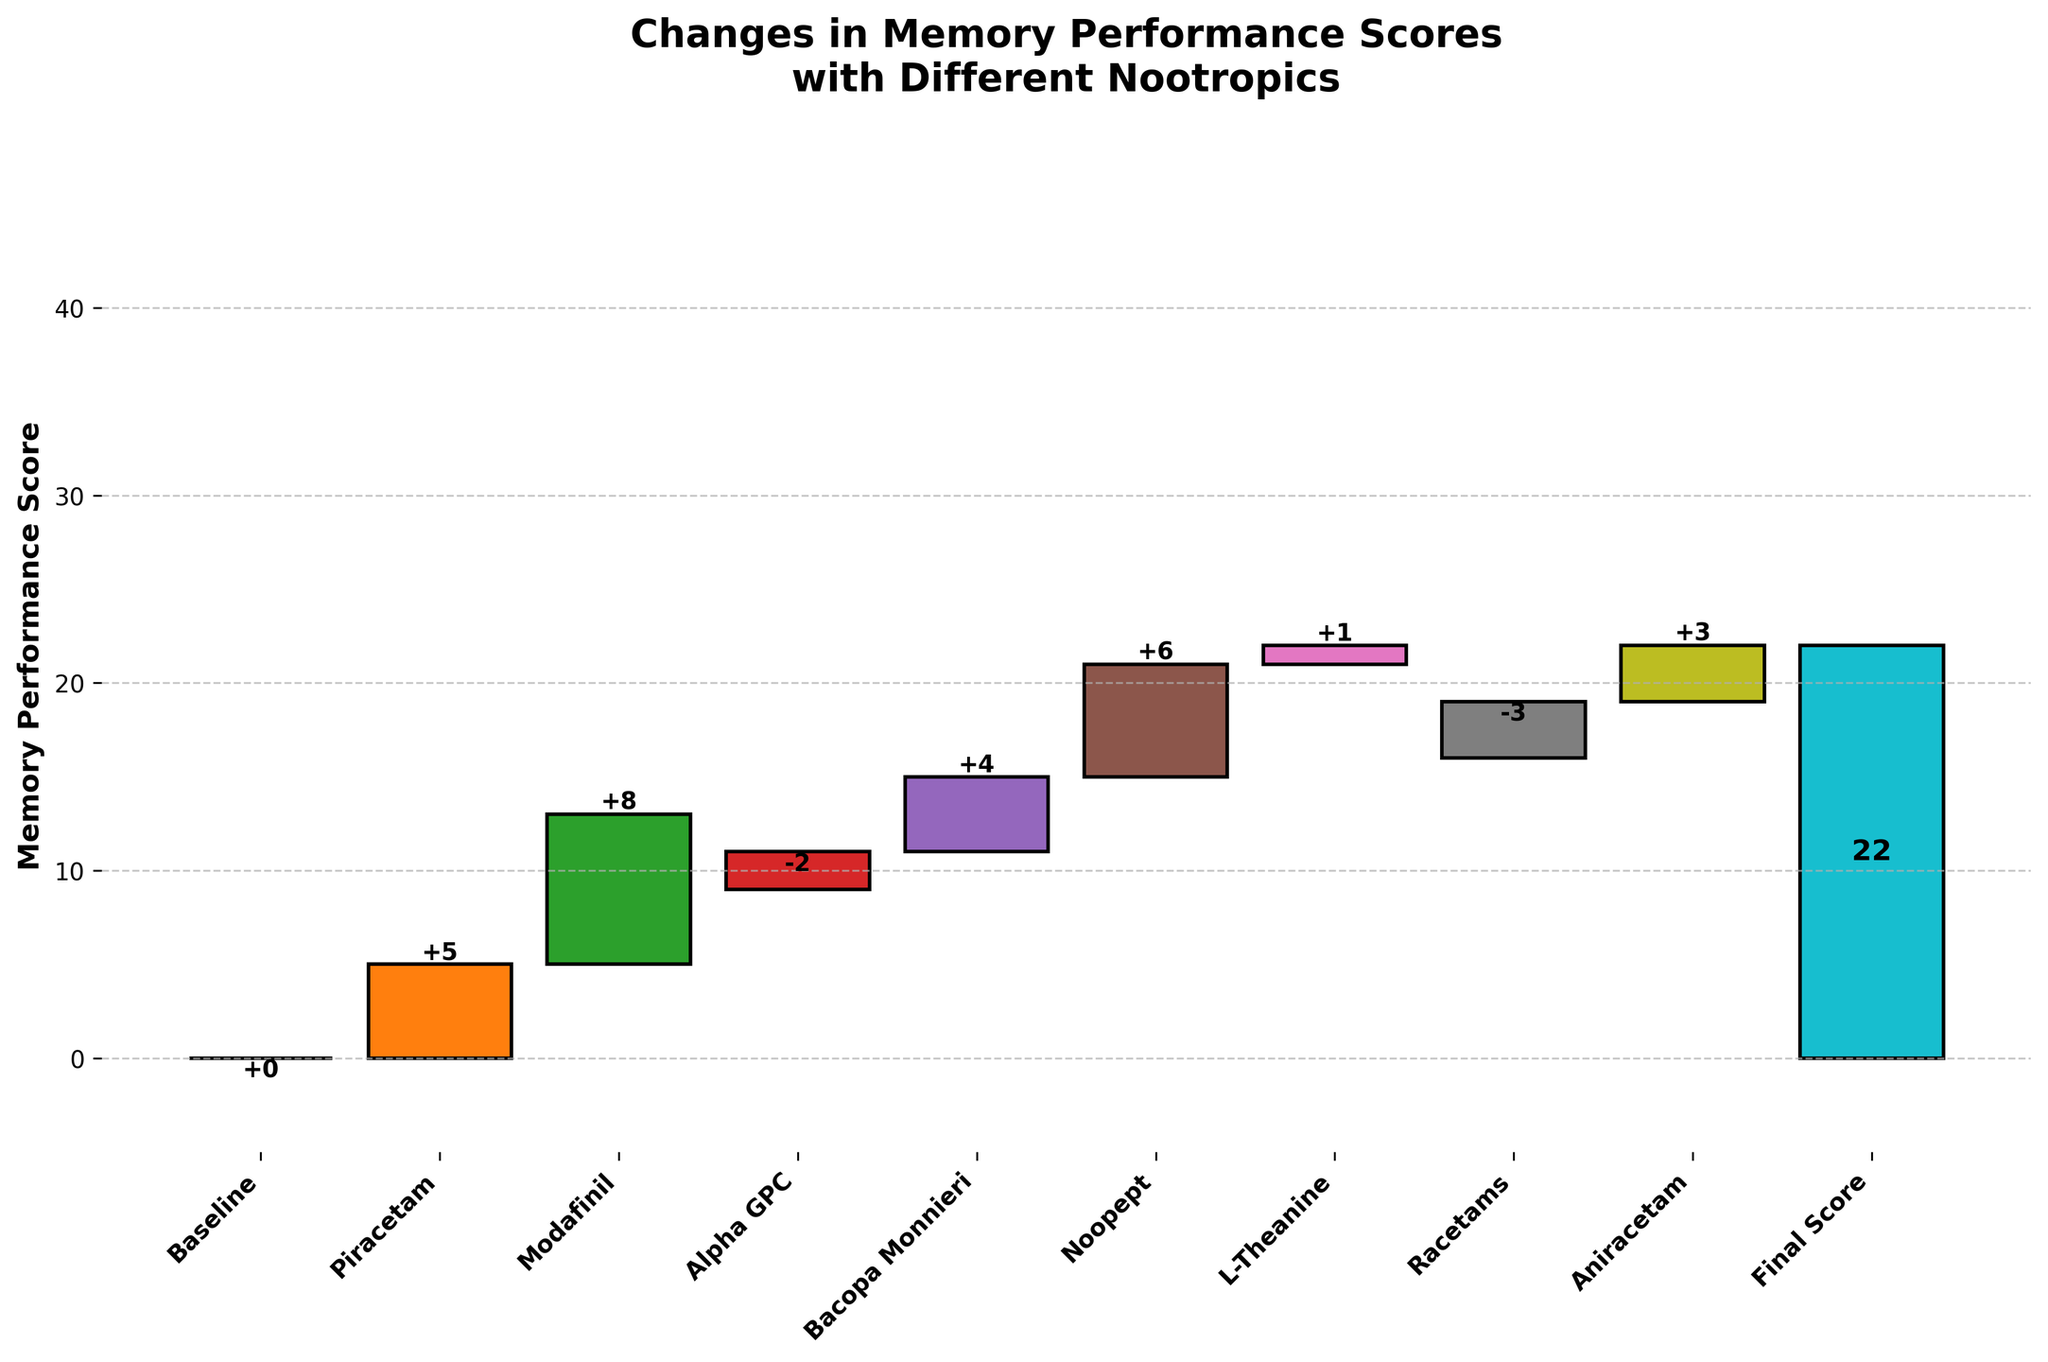what is the title of the chart? The title is displayed at the top of the figure and it summarizes the main focus of the visual representation.
Answer: Changes in Memory Performance Scores with Different Nootropics How many categories are represented in the figure? To determine the number of categories, count the individual labels on the x-axis.
Answer: 10 Which nootropic resulted in the largest increase in memory performance score? The height of the bars on the positive side of the y-axis indicates the increase in scores. The tallest bar represents the largest increase.
Answer: Modafinil What are the cumulative memory performance scores after Alpha GPC? Sum the values from Baseline to Alpha GPC: 0 (Baseline) + 5 (Piracetam) + 8 (Modafinil) - 2 (Alpha GPC) = 11.
Answer: 11 What is the final score after all nootropics were applied? The final score is indicated at the end of the waterfall chart, often in a distinct color.
Answer: 22 By how much did Bacopa Monnieri improve the memory score? Locate Bacopa Monnieri on the x-axis and read the value on the y-axis associated with it.
Answer: +4 Compare the effects of Aniracetam and Racetams on memory performance. Which has a larger impact? Aniracetam and Racetams values on the y-axis indicate the impact: +3 for Aniracetam and -3 for Racetams. Compare these values.
Answer: Aniracetam What is the total score change contributed by nootropics with negative impacts? Sum the values of all the nootropics with negative impacts: -2 (Alpha GPC) - 3 (Racetams) = -5.
Answer: -5 How does the score change produced by Piracetam compare to L-Theanine? Compare the y-axis values for Piracetam and L-Theanine: +5 for Piracetam and +1 for L-Theanine.
Answer: Piracetam produces a larger change 